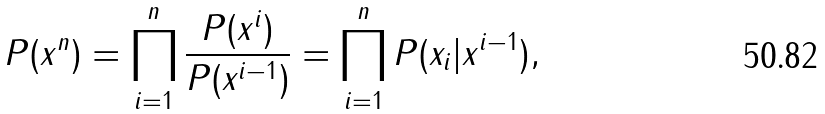<formula> <loc_0><loc_0><loc_500><loc_500>P ( x ^ { n } ) = \prod _ { i = 1 } ^ { n } \frac { P ( x ^ { i } ) } { P ( x ^ { i - 1 } ) } = \prod _ { i = 1 } ^ { n } P ( x _ { i } | x ^ { i - 1 } ) ,</formula> 